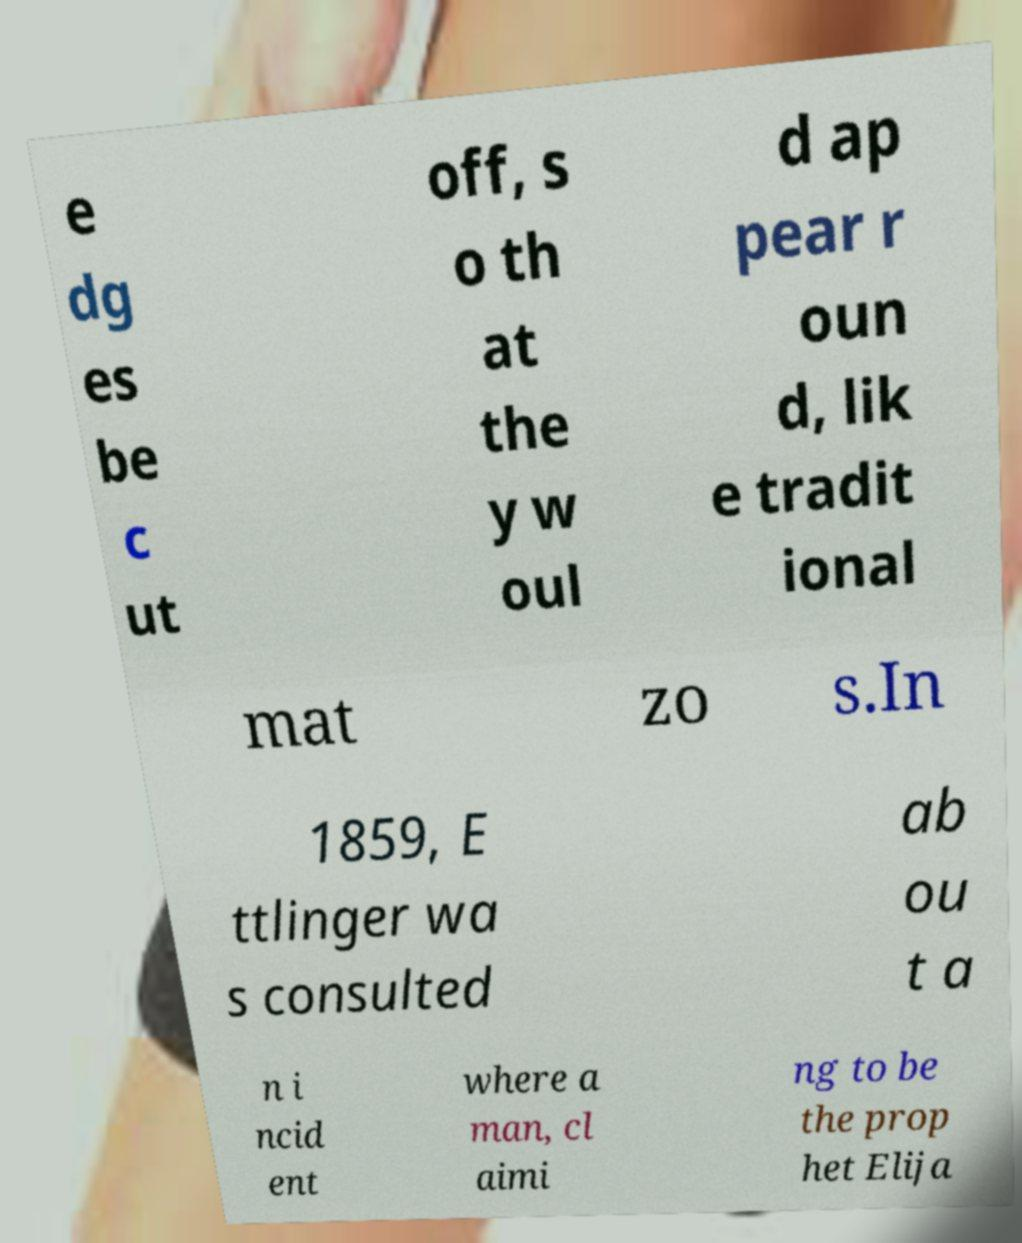What messages or text are displayed in this image? I need them in a readable, typed format. e dg es be c ut off, s o th at the y w oul d ap pear r oun d, lik e tradit ional mat zo s.In 1859, E ttlinger wa s consulted ab ou t a n i ncid ent where a man, cl aimi ng to be the prop het Elija 